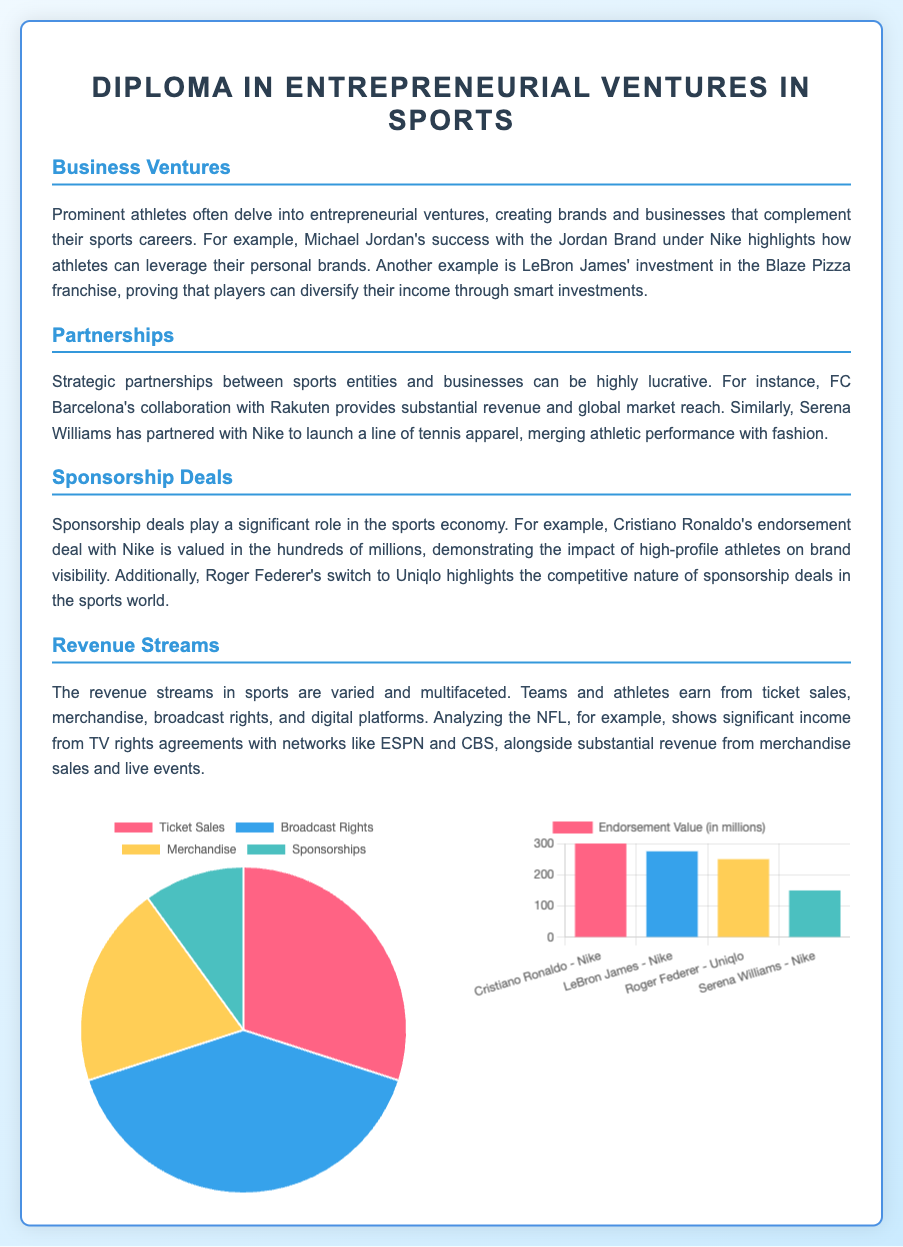What are the revenue sources for a professional sports team? The revenue sources are represented in the pie chart showing the proportions of ticket sales, broadcast rights, merchandise, and sponsorships.
Answer: Ticket Sales, Broadcast Rights, Merchandise, Sponsorships What is the percentage of revenue from broadcast rights? The pie chart specifies the percentage share of each revenue source, with broadcast rights contributing 40%.
Answer: 40% Who is associated with the endorsement deal valued at 300 million? According to the bar chart, Cristiano Ronaldo has an endorsement deal with Nike valued at 300 million.
Answer: Cristiano Ronaldo What is the endorsement value of LeBron James' deal with Nike? The bar chart indicates that LeBron James' endorsement deal with Nike is valued at 275 million.
Answer: 275 million Which company partnered with FC Barcelona? The document states that FC Barcelona has a collaboration with Rakuten.
Answer: Rakuten What revenue stream accounts for the least percentage? The pie chart displays that sponsorships account for the smallest portion of revenue at 10%.
Answer: 10% How many endorsement deals are represented in the bar chart? The bar chart lists four endorsement deals: Cristiano Ronaldo, LeBron James, Roger Federer, and Serena Williams.
Answer: Four 